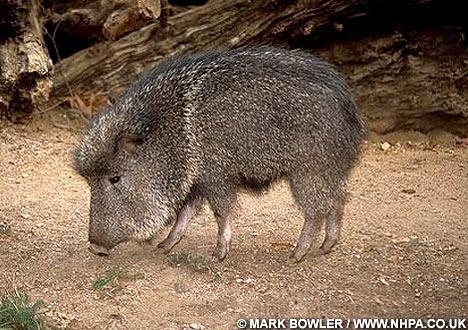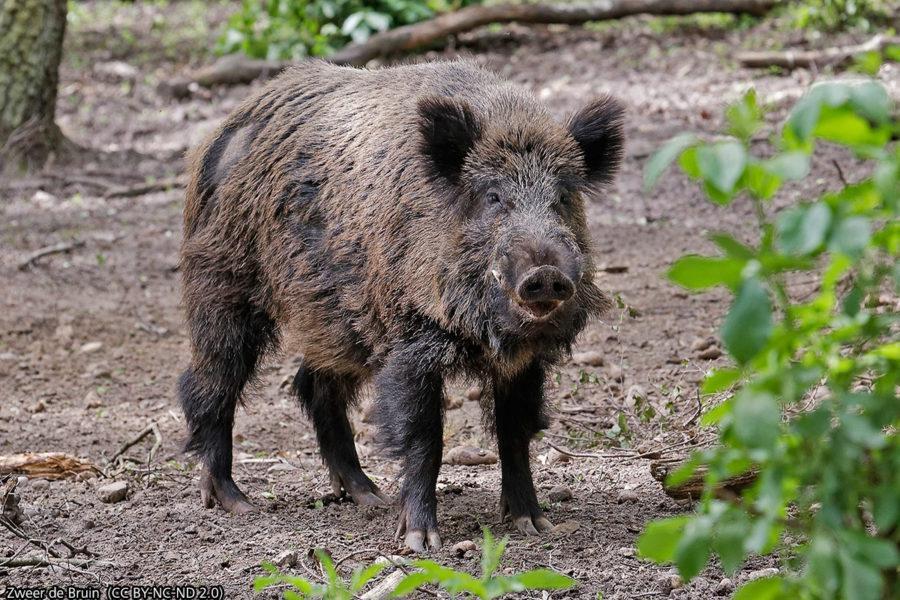The first image is the image on the left, the second image is the image on the right. Assess this claim about the two images: "In the right image, there's a wild boar with her piglets.". Correct or not? Answer yes or no. No. The first image is the image on the left, the second image is the image on the right. Considering the images on both sides, is "A mother warhog is rooting with her nose to the ground with her piglets near her" valid? Answer yes or no. No. 